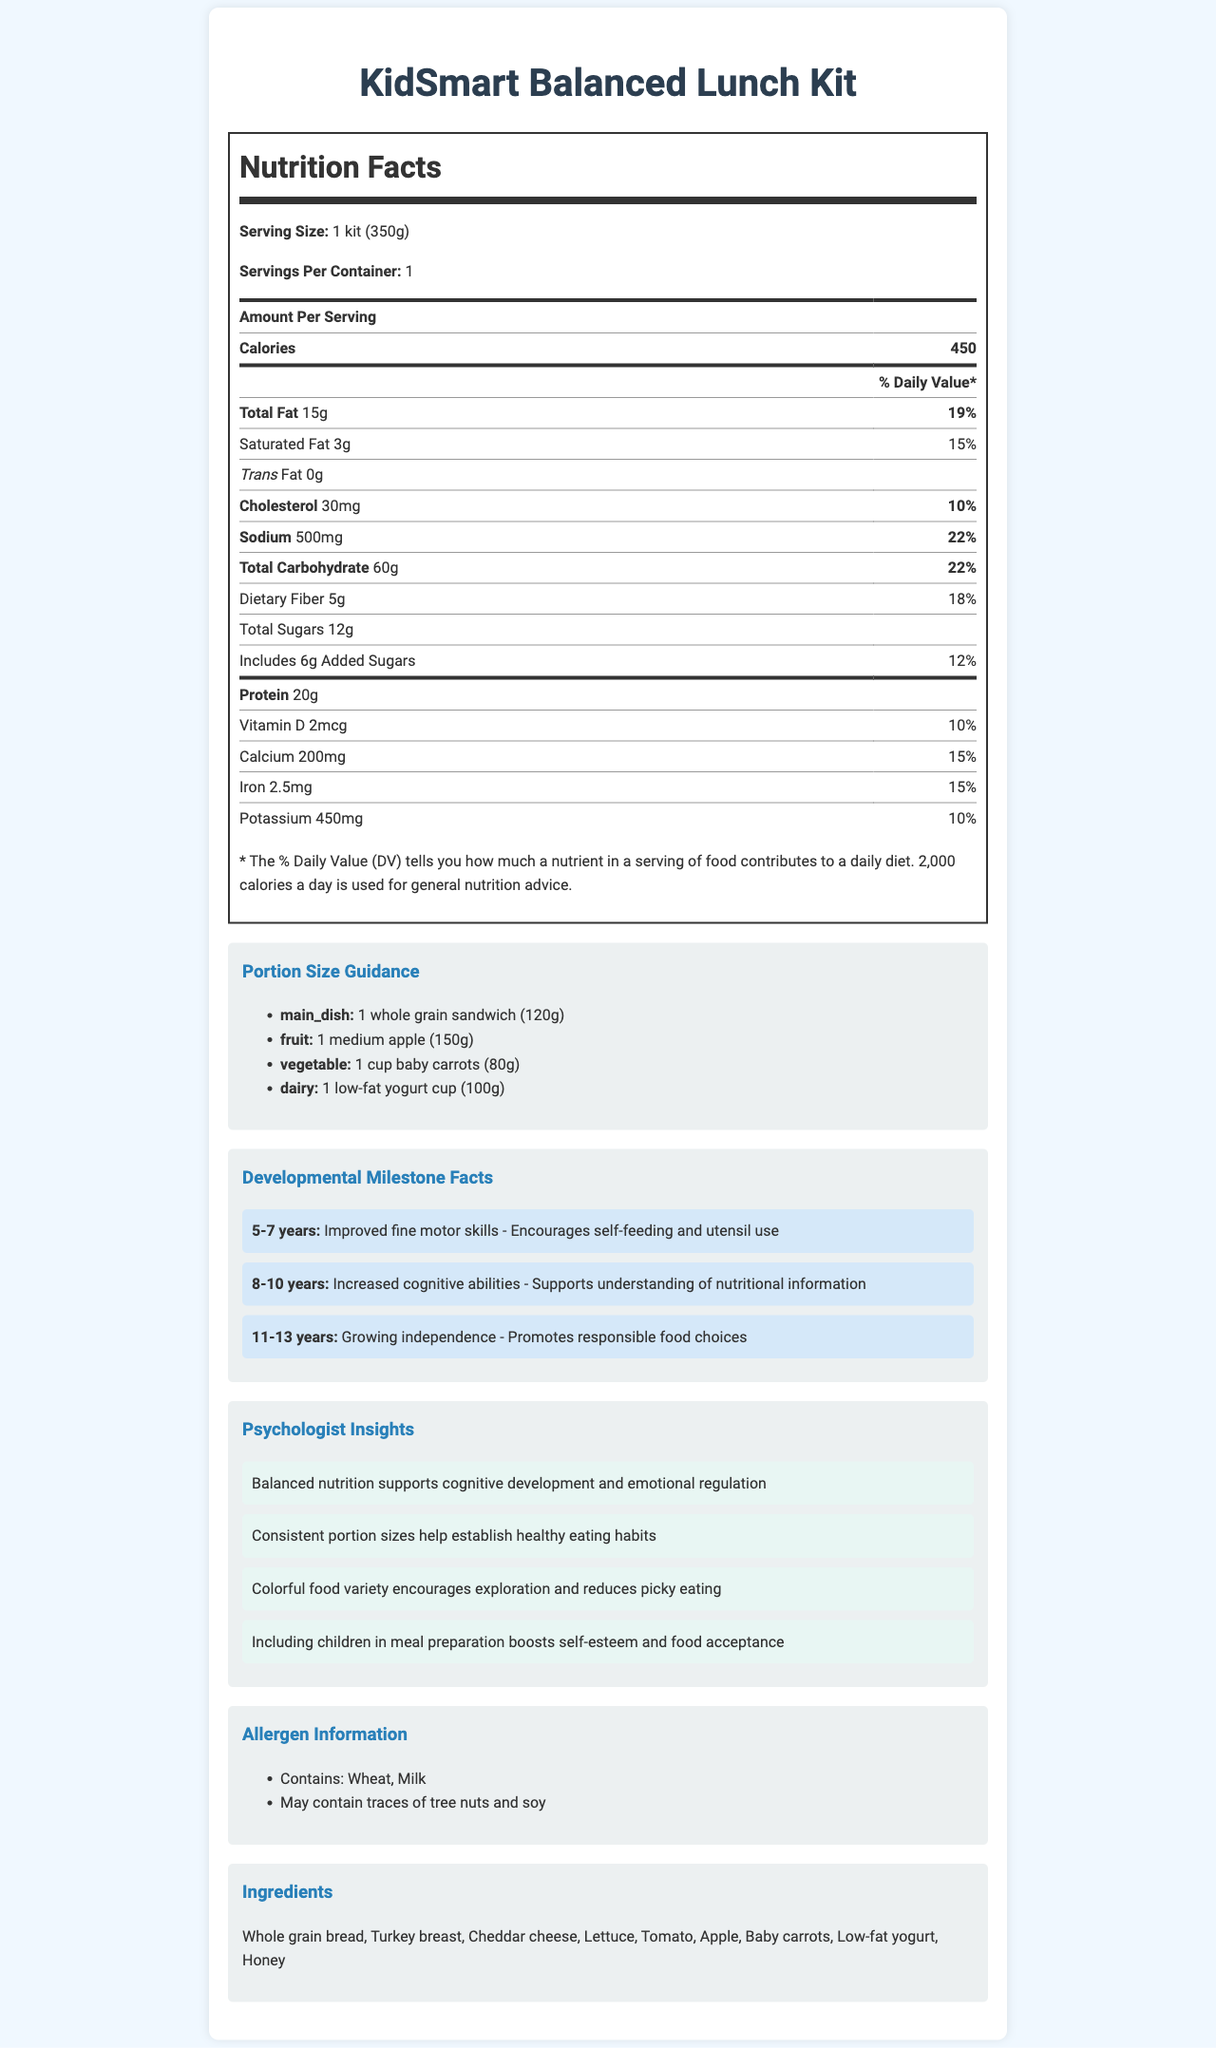what is the serving size for the KidSmart Balanced Lunch Kit? The serving size is mentioned directly under the nutrition facts label as "Serving Size: 1 kit (350g)".
Answer: 1 kit (350g) how many calories are there per serving? The number of calories per serving is stated in the nutrition facts under "Calories: 450".
Answer: 450 what is the % daily value of total fat? The % daily value of total fat is listed as "Total Fat 15g 19%" in the nutrition facts table.
Answer: 19% how much protein is in one serving? The amount of protein is listed as "Protein 20g" in the nutrition facts table.
Answer: 20g what are the allergen warnings for this product? The allergen information section lists "Contains: Wheat, Milk" and "May contain traces of tree nuts and soy".
Answer: Contains: Wheat, Milk; May contain traces of tree nuts and soy which of the following is a developmental milestone for children aged 5-7 years? A. Growing independence B. Improved fine motor skills C. Increased cognitive abilities D. Enhanced social skills The developmental milestone facts section states that for ages 5-7 years, the milestone is "Improved fine motor skills".
Answer: B which item is part of the portion size guidance for dairy? A. Cheddar cheese B. Low-fat yogurt cup  C. Milk D. Baby carrots The portion size guidance section lists "dairy" as "1 low-fat yogurt cup (100g)".
Answer: B how much vitamin D does the KidSmart Balanced Lunch Kit provide? The nutrition facts table lists the vitamin D content as "Vitamin D 2mcg".
Answer: 2mcg does the KidSmart Balanced Lunch Kit contain trans fat? The nutrition facts table shows "Trans Fat 0g", indicating there is no trans fat.
Answer: No summarize the main contents of the document. The document encompasses a variety of sections providing detailed nutritional data, portion recommendations, developmental benefits, and potential allergens, along with psychologist-backed insights to support the nutritional choices for children.
Answer: The document provides nutritional information for the KidSmart Balanced Lunch Kit, including serving size, calories, fat, protein, vitamins, and mineral content. It includes portion size guidance for different food categories, developmental milestone facts for children, psychologist insights regarding child nutrition, allergen information, and a list of ingredients. how much calcium is in the KidSmart Balanced Lunch Kit? The nutrition facts table lists calcium as "Calcium 200mg 15%".
Answer: 200mg why is a colorful food variety recommended according to the psychologist insights? A. Boosts energy levels B. Encourages exploration and reduces picky eating C. Increases protein intake D. Supports immunity The psychologist insights section mentions "Colorful food variety encourages exploration and reduces picky eating".
Answer: B can we identify if the product is certified organic from the document? The document does not provide information regarding any organic certification.
Answer: Not enough information what is the relevance of improved fine motor skills for ages 5-7 years? In the developmental milestone facts section, it is stated that "Improved fine motor skills" for ages 5-7 years "Encourages self-feeding and utensil use".
Answer: Encourages self-feeding and utensil use 